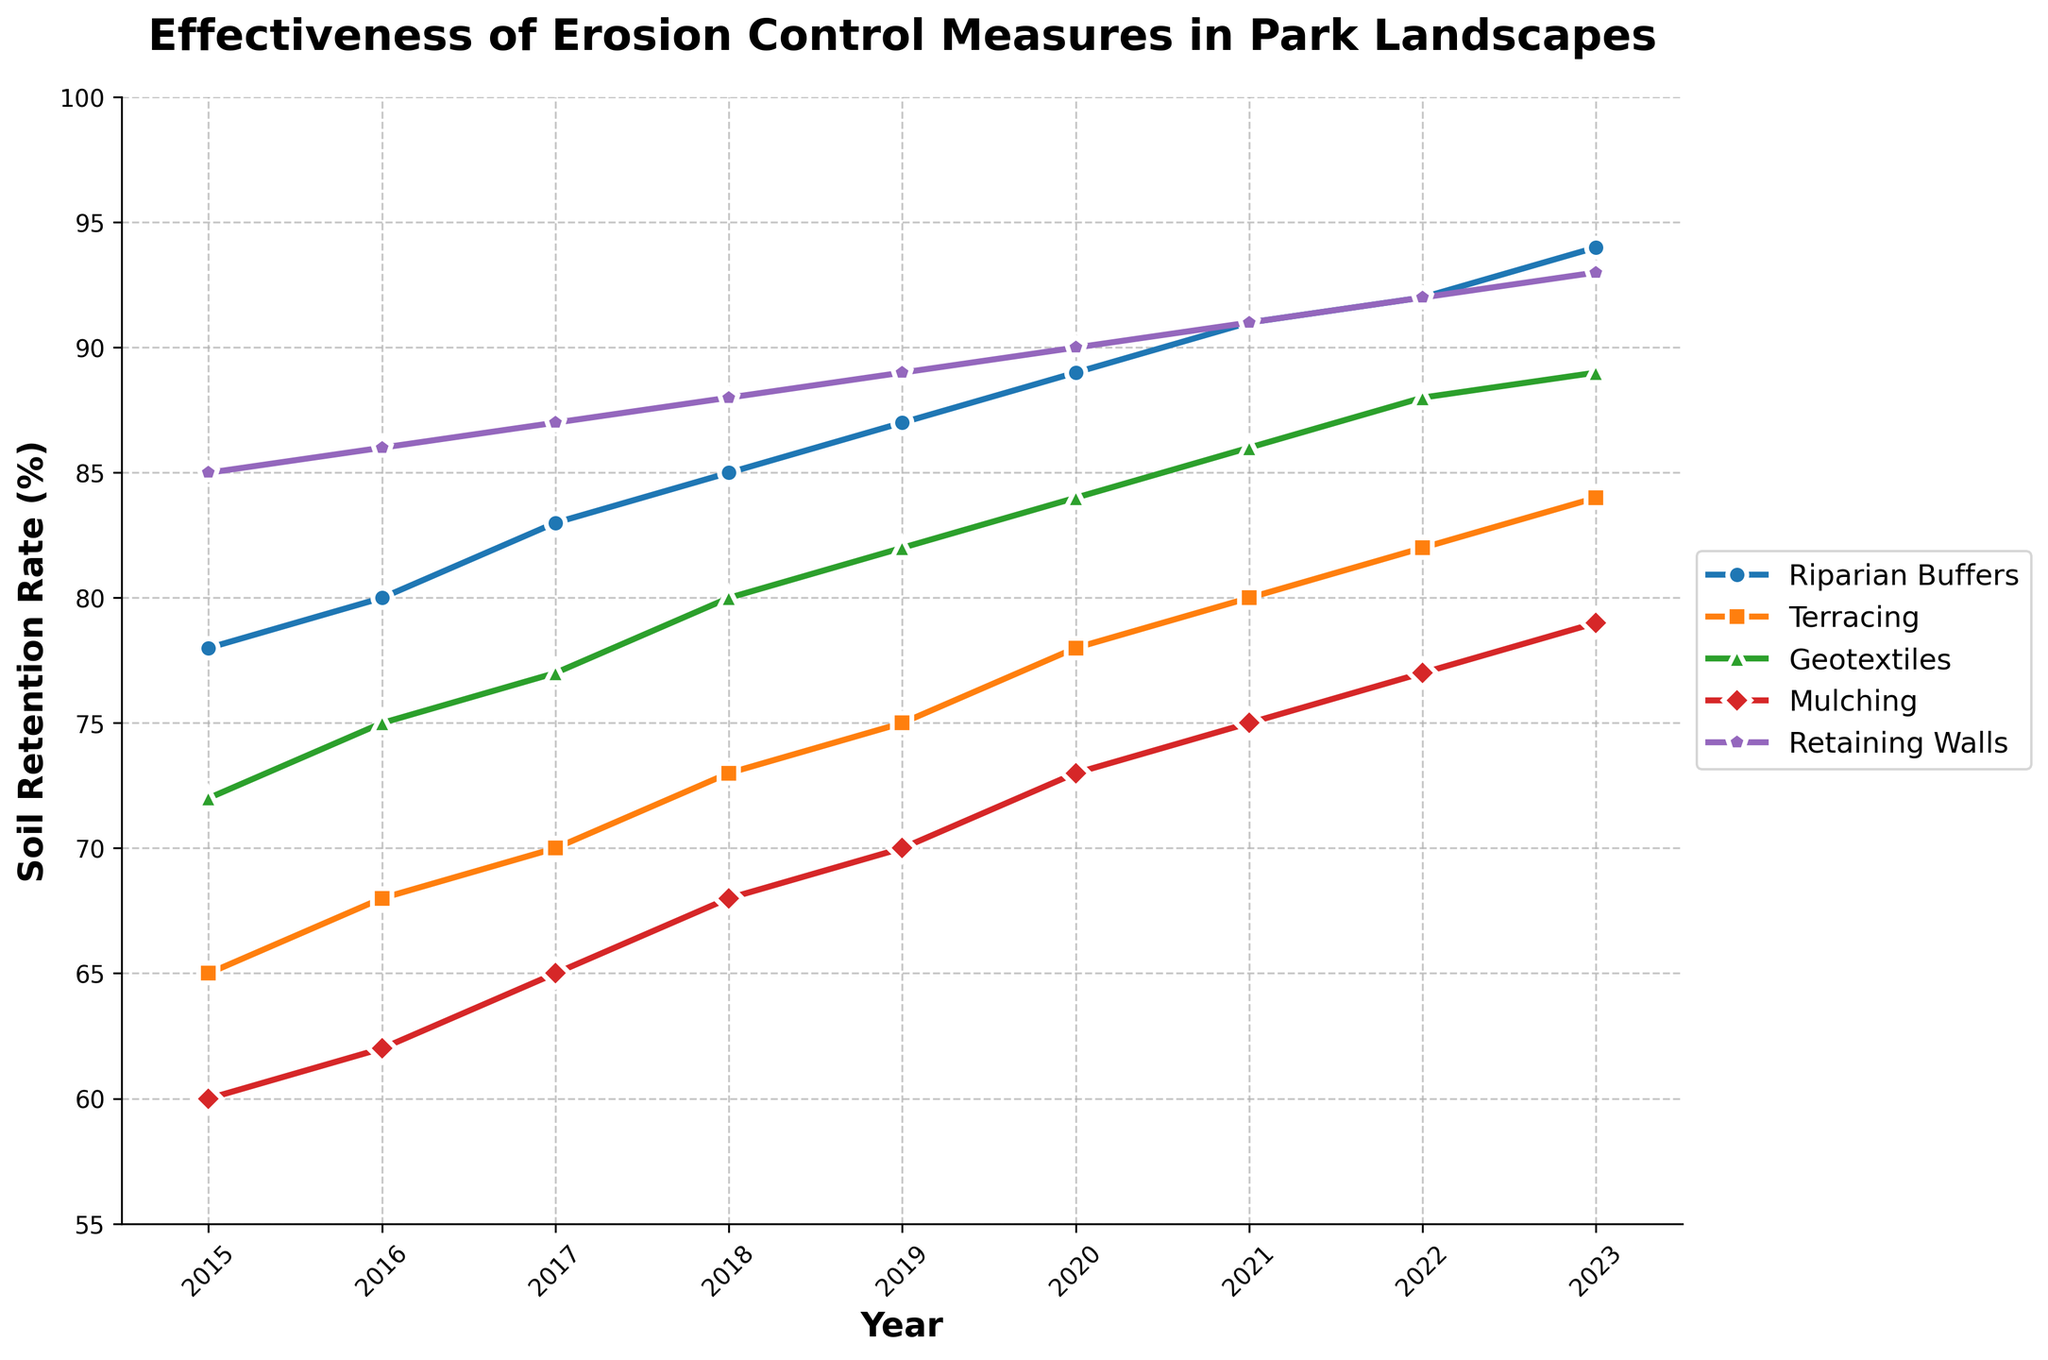What year did Riparian Buffers have a higher soil retention rate than Retaining Walls? By visually inspecting the lines on the chart, we compare the progression of the retention rates. Notice that Riparian Buffers consistently show a lower soil retention rate than Retaining Walls throughout the entire time period. Therefore, there is no year when Riparian Buffers have a higher soil retention rate than Retaining Walls.
Answer: None Between which two years did Geotextiles experience the highest growth in soil retention rate? Check the changes in the slope of the Geotextiles line between consecutive years. The highest growth can be observed by comparing the retention rates between 2021 and 2022, where the increase is from 86 to 88, which is a change of 2 percentage points.
Answer: 2021 and 2022 Which erosion control measure had the smallest increase in soil retention rate from 2015 to 2023? Calculate the difference in soil retention rates from 2015 to 2023 for each measure: Riparian Buffers (94-78=16), Terracing (84-65=19), Geotextiles (89-72=17), Mulching (79-60=19), Retaining Walls (93-85=8). Retaining Walls had the smallest increase.
Answer: Retaining Walls How does the soil retention rate of Mulching in 2019 compare to that of Geotextiles in 2017? Look at the points for Mulching in 2019 (70) and Geotextiles in 2017 (77) on the chart. Mulching in 2019 has a lower soil retention rate compared to Geotextiles in 2017.
Answer: Lower What can be inferred about the overall trend in soil retention rates for all erosion control measures from 2015 to 2023? By analyzing the general direction of all the lines from 2015 to 2023, it can be observed that each line trends upwards, indicating that the soil retention rates for all erosion control measures have generally increased over time.
Answer: Increasing Which erosion control measure shows the most visual consistency (least fluctuation) in its soil retention rate over the years? This can be inferred by observing which line on the chart is the smoothest without many irregular changes. Retaining Walls show the most visual consistency with a smooth and steady upward trend.
Answer: Retaining Walls What is the difference in soil retention rate between the highest and lowest performing erosion control measure in 2023? Identify the highest and lowest performing measures in 2023: Riparian Buffers (94) and Mulching (79). The difference is 94 - 79 = 15.
Answer: 15 